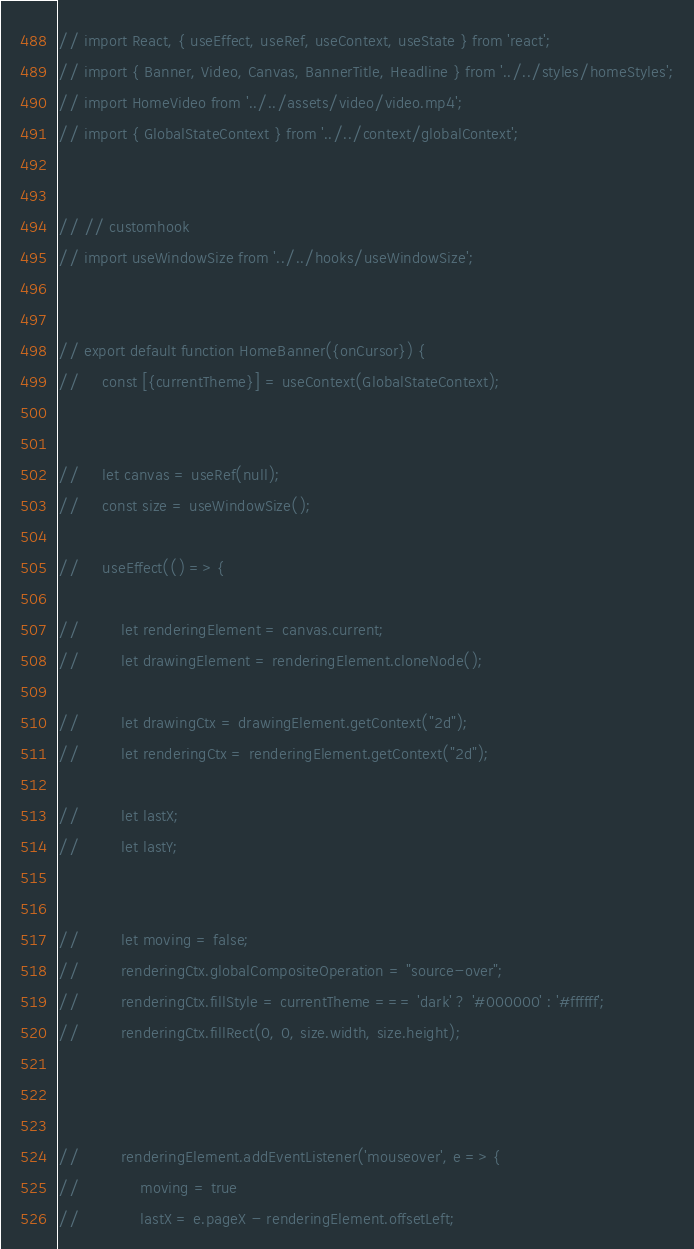Convert code to text. <code><loc_0><loc_0><loc_500><loc_500><_JavaScript_>// import React, { useEffect, useRef, useContext, useState } from 'react';
// import { Banner, Video, Canvas, BannerTitle, Headline } from '../../styles/homeStyles';
// import HomeVideo from '../../assets/video/video.mp4';
// import { GlobalStateContext } from '../../context/globalContext';


// // customhook
// import useWindowSize from '../../hooks/useWindowSize';


// export default function HomeBanner({onCursor}) {
//     const [{currentTheme}] = useContext(GlobalStateContext);
    

//     let canvas = useRef(null);
//     const size = useWindowSize();

//     useEffect(() => {
        
//         let renderingElement = canvas.current;
//         let drawingElement = renderingElement.cloneNode();

//         let drawingCtx = drawingElement.getContext("2d");
//         let renderingCtx = renderingElement.getContext("2d");

//         let lastX;
//         let lastY;
        

//         let moving = false;
//         renderingCtx.globalCompositeOperation = "source-over";
//         renderingCtx.fillStyle = currentTheme === 'dark' ? '#000000' : '#ffffff';
//         renderingCtx.fillRect(0, 0, size.width, size.height);



//         renderingElement.addEventListener('mouseover', e => {
//             moving = true
//             lastX = e.pageX - renderingElement.offsetLeft;</code> 